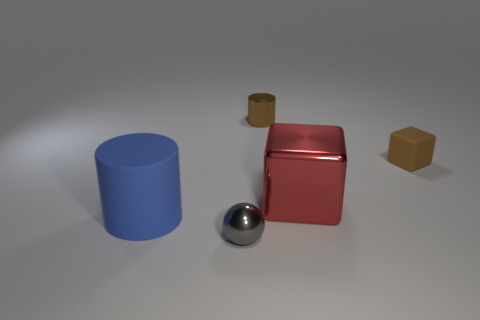What material is the tiny cube that is the same color as the small shiny cylinder? rubber 